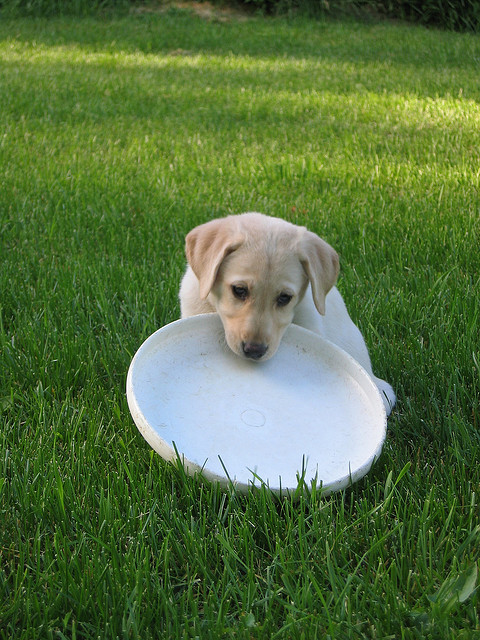Can you tell me more about the dog's breed? Sure, the dog in the photo appears to be a Labrador Retriever, a breed known for its friendly nature and love of retrieving games, which includes playing with Frisbees. They are often yellow, black, or chocolate in color, and this one looks like a yellow Labrador puppy. Do you think the dog just finished playing? It's quite likely. Labrador Retrievers are energetic dogs who enjoy physical activity. The presence of the Frisbee suggests that the dog has been playing fetch and is taking a moment to rest. What might the dog be thinking? While we can't know for sure what a dog is thinking, it might be eagerly waiting for the next round of play or simply enjoying the outdoors. The attentive expression could indicate readiness for more fun. 